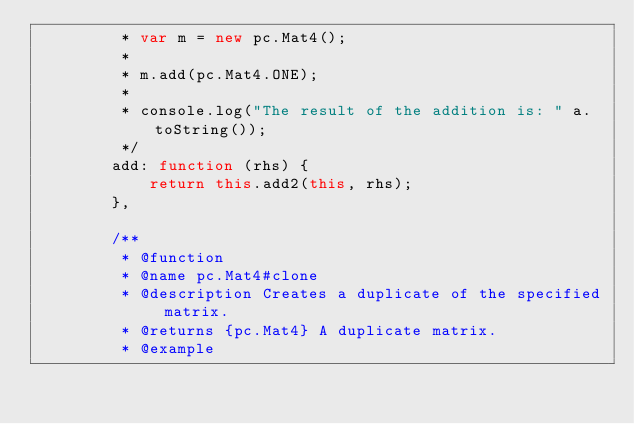Convert code to text. <code><loc_0><loc_0><loc_500><loc_500><_JavaScript_>         * var m = new pc.Mat4();
         *
         * m.add(pc.Mat4.ONE);
         *
         * console.log("The result of the addition is: " a.toString());
         */
        add: function (rhs) {
            return this.add2(this, rhs);
        },

        /**
         * @function
         * @name pc.Mat4#clone
         * @description Creates a duplicate of the specified matrix.
         * @returns {pc.Mat4} A duplicate matrix.
         * @example</code> 